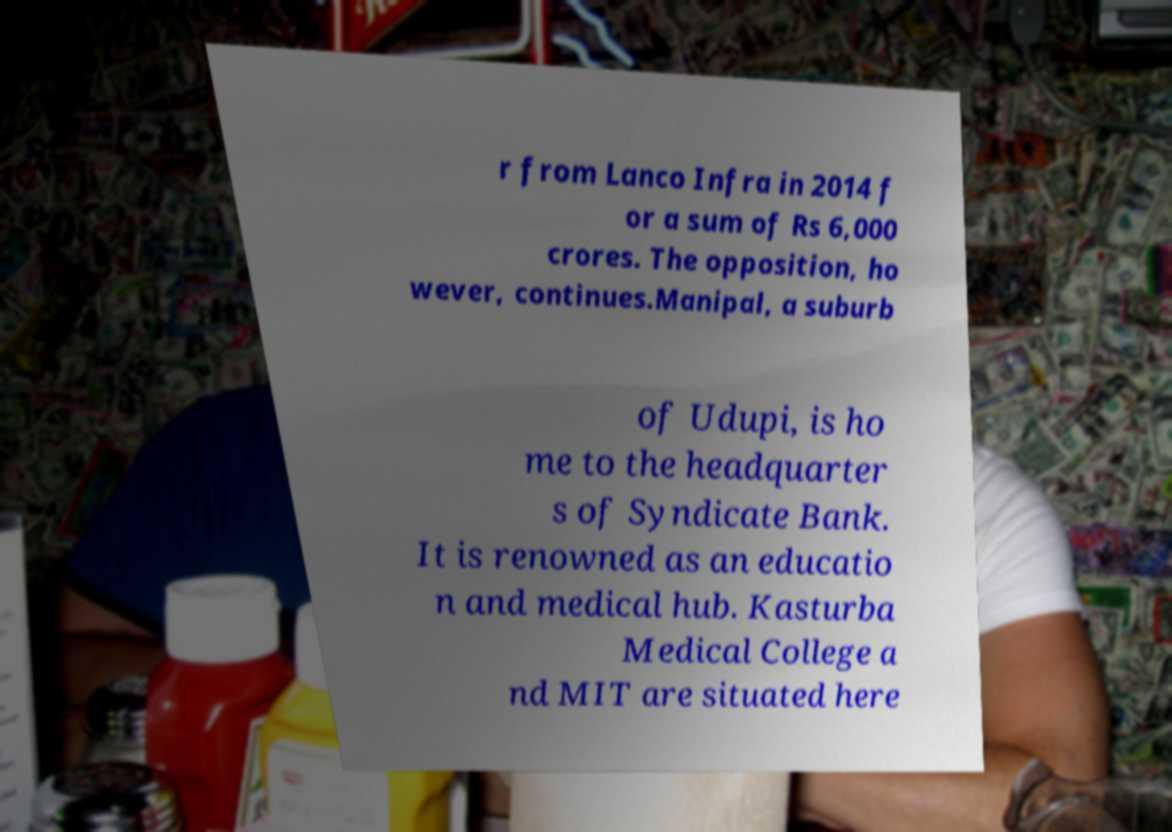Could you extract and type out the text from this image? r from Lanco Infra in 2014 f or a sum of Rs 6,000 crores. The opposition, ho wever, continues.Manipal, a suburb of Udupi, is ho me to the headquarter s of Syndicate Bank. It is renowned as an educatio n and medical hub. Kasturba Medical College a nd MIT are situated here 